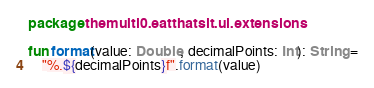<code> <loc_0><loc_0><loc_500><loc_500><_Kotlin_>package themulti0.eatthatsit.ui.extensions

fun format(value: Double, decimalPoints: Int): String =
    "%.${decimalPoints}f".format(value)</code> 